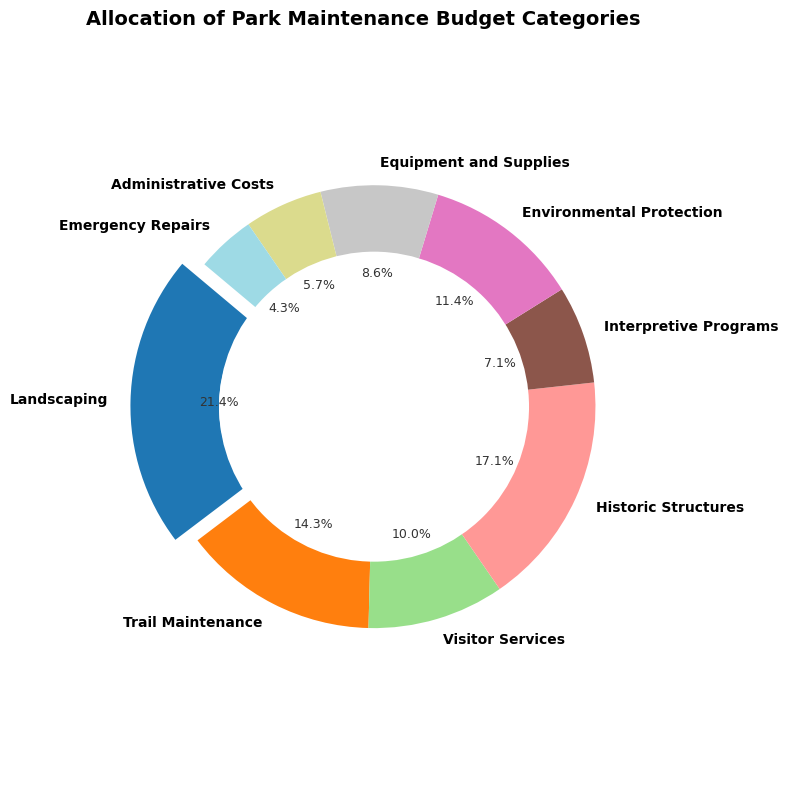Which budget category has the highest allocation? To find the budget category with the highest allocation, refer to the figure to see which category has the largest segment. The segment with the highest percentage will indicate the category with the highest allocation.
Answer: Landscaping What's the total budget allocation for Trail Maintenance and Visitor Services? Sum the amounts allocated to Trail Maintenance and Visitor Services by locating their respective segments in the figure. Trail Maintenance is $10,000 and Visitor Services is $7,000, so their total is $10,000 + $7,000.
Answer: $17,000 Which slice is highlighted in the figure and why? Notice the slice that is slightly separated from the rest in the ring chart. This usually signifies the category with the highest allocation, which is Landscaping in this case, as it has the largest share.
Answer: Landscaping, because it has the highest allocation What percentage of the total budget is allocated to Environmental Protection? Locate the Environmental Protection segment and note its percentage value as indicated in the figure. The figure shows each segment's percentage clearly.
Answer: 8.9% How much more is allocated to Historic Structures than Equipment and Supplies? Find the amounts for both categories in the figure. Historic Structures have $12,000 and Equipment and Supplies have $6,000. The difference is calculated as $12,000 - $6,000.
Answer: $6,000 What is the combined budget for Interpretive Programs, Environmental Protection, and Emergency Repairs? Sum the amounts allocated to these three categories by locating their segments in the figure. The amounts are $5,000 (Interpretive Programs), $8,000 (Environmental Protection), and $3,000 (Emergency Repairs). Their combined budget is $5,000 + $8,000 + $3,000.
Answer: $16,000 Which category has the smallest allocation and how much is it? Identify the segment with the smallest percentage in the ring chart. This segment will represent the category with the smallest allocation.
Answer: Emergency Repairs, $3,000 What is the average budget allocation across all categories? Sum all the category amounts and then divide by the number of categories. The total sum is $15,000 + $10,000 + $7,000 + $12,000 + $5,000 + $8,000 + $6,000 + $4,000 + $3,000 = $70,000. There are 9 categories, so the average is $70,000 / 9.
Answer: $7,778 How does the budget for Administrative Costs compare to the budget for Equipment and Supplies? Locate the amounts for both categories in the figure. Administrative Costs are $4,000 and Equipment and Supplies are $6,000. Compare the two values.
Answer: Administrative Costs have $2,000 less than Equipment and Supplies What is the difference between the highest and lowest budget allocations? Identify the highest and lowest allocation amounts from the figure. The highest is Landscaping at $15,000 and the lowest is Emergency Repairs at $3,000. Subtract the lowest from the highest: $15,000 - $3,000.
Answer: $12,000 